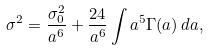Convert formula to latex. <formula><loc_0><loc_0><loc_500><loc_500>\sigma ^ { 2 } = \frac { \sigma _ { 0 } ^ { 2 } } { a ^ { 6 } } + \frac { 2 4 } { a ^ { 6 } } \int a ^ { 5 } \Gamma ( a ) \, d a ,</formula> 